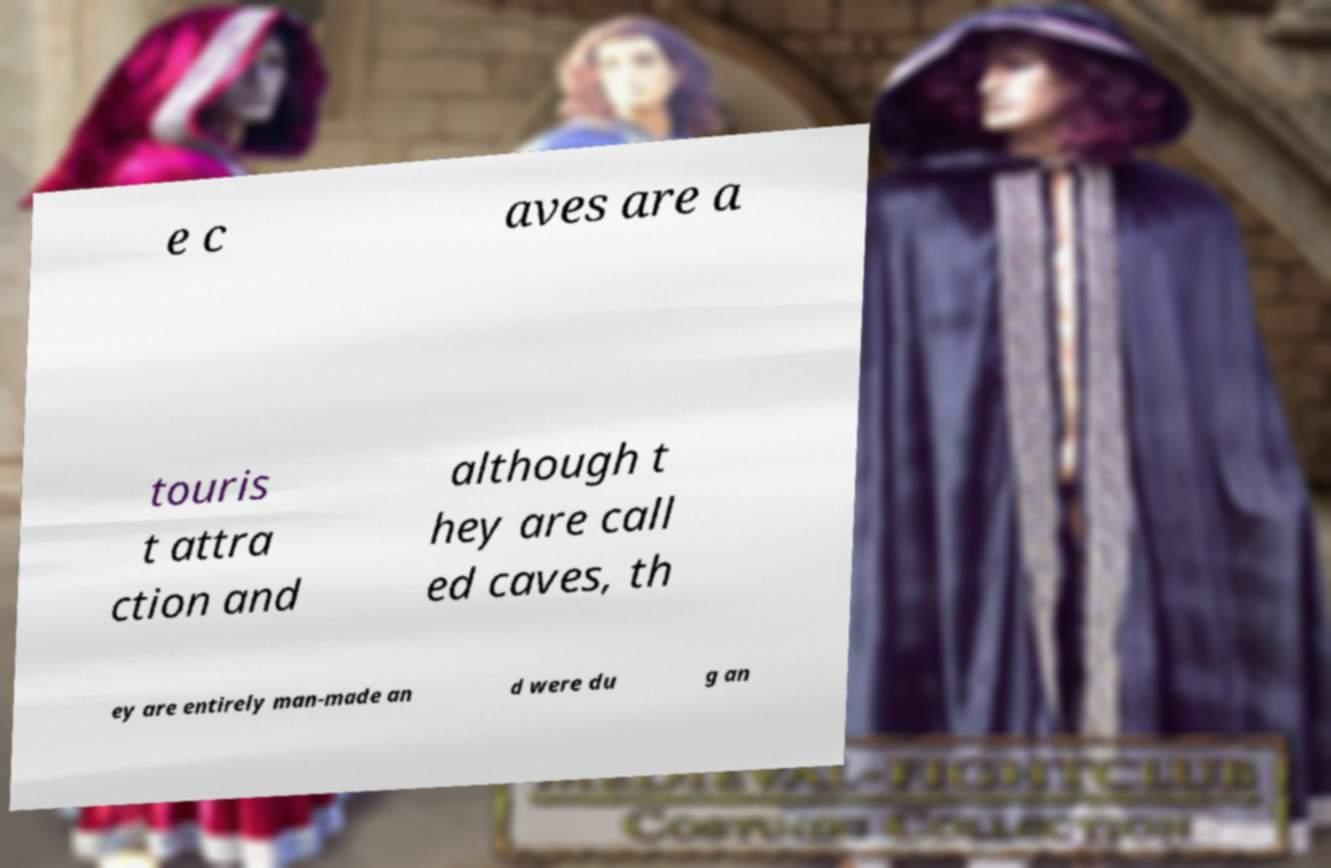Could you assist in decoding the text presented in this image and type it out clearly? e c aves are a touris t attra ction and although t hey are call ed caves, th ey are entirely man-made an d were du g an 